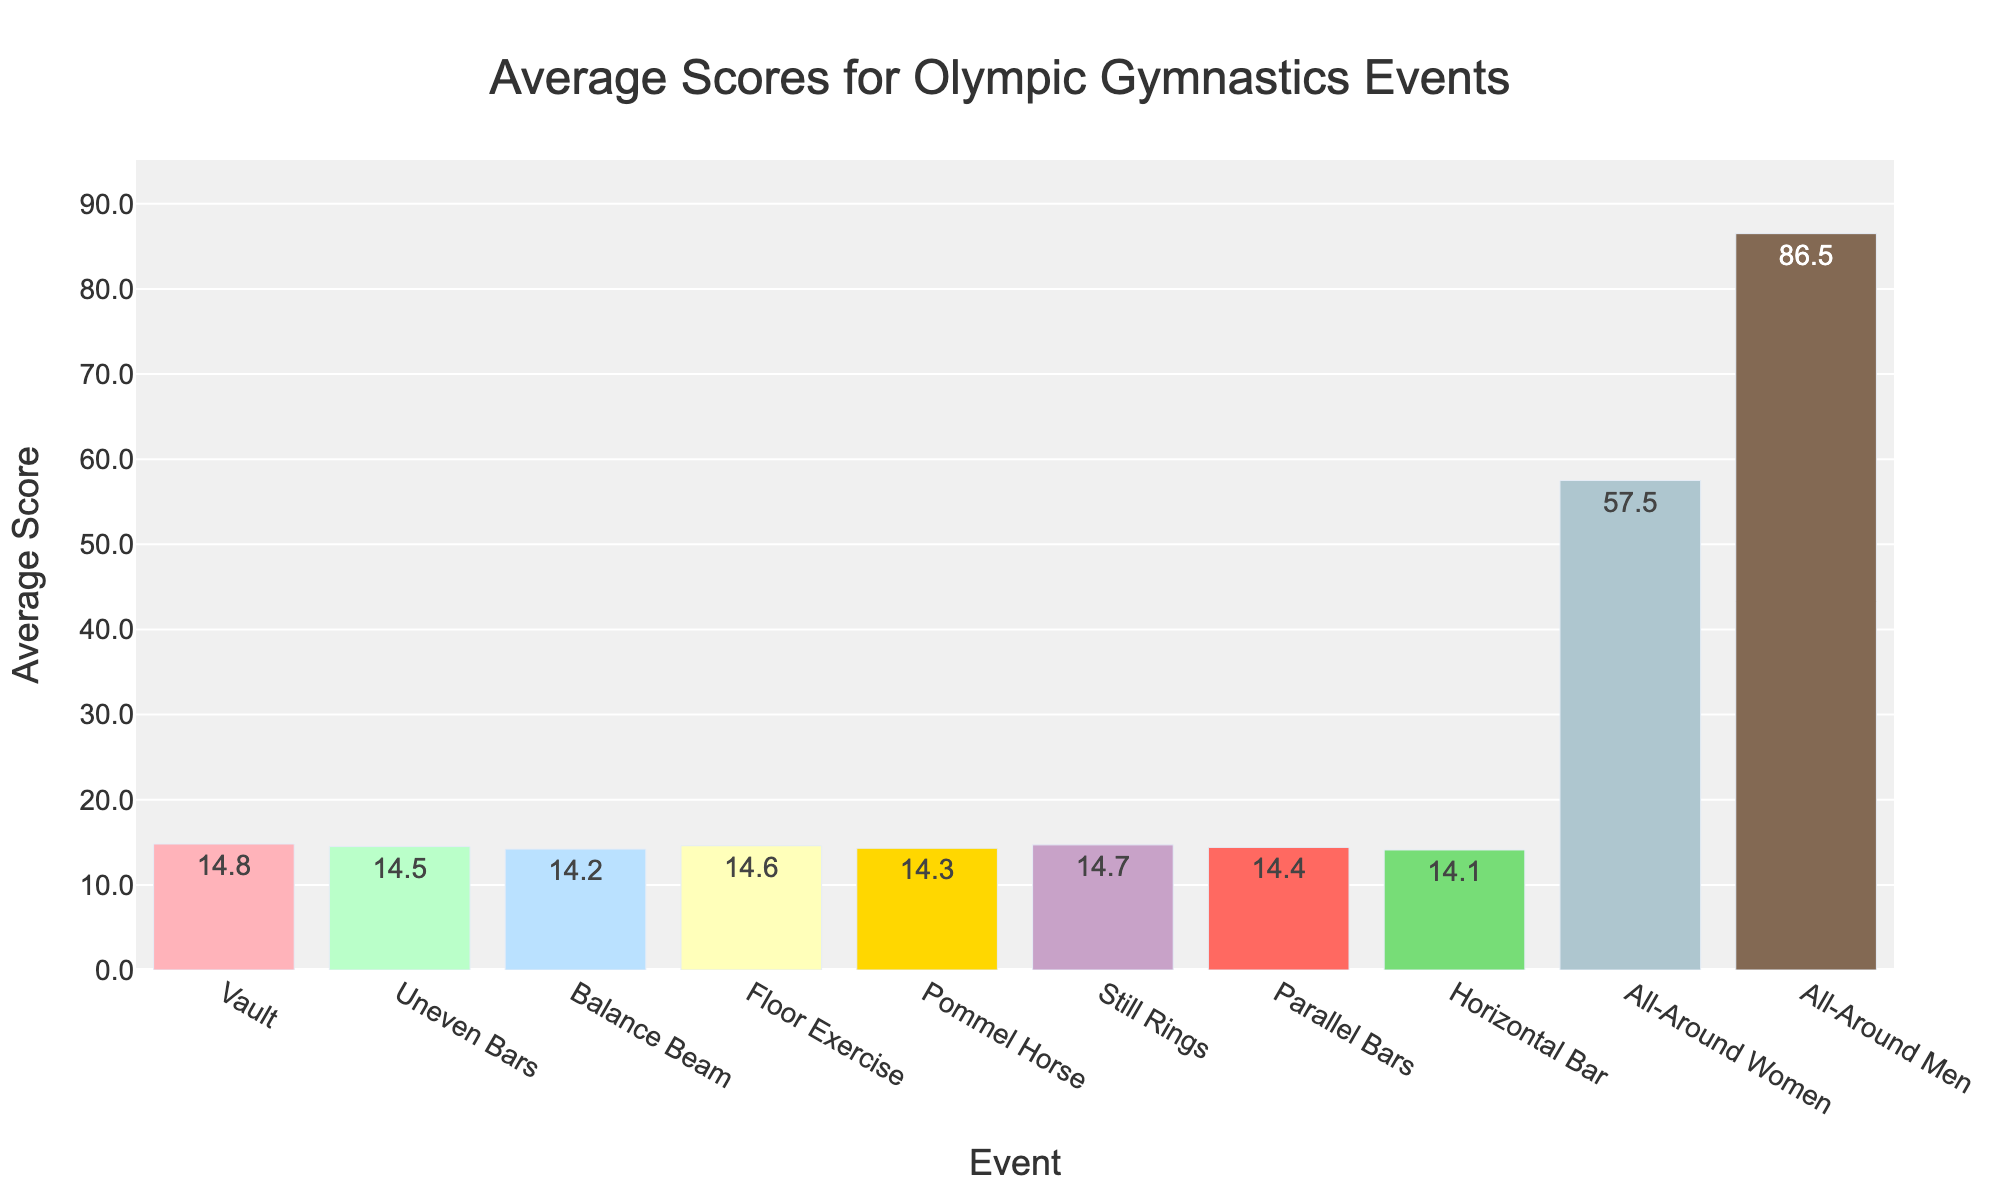What's the event with the highest average score? The highest average score can be identified by finding the tallest bar in the chart, which represents the event. The 'All-Around Men' event has the highest bar with an average score of 86.5.
Answer: All-Around Men Which event has the lowest average score? The event with the lowest average score can be determined by finding the shortest bar in the chart. The 'Horizontal Bar' event has the lowest bar with an average score of 14.1.
Answer: Horizontal Bar What is the difference in average scores between the 'Vault' and 'Balance Beam'? The average score for Vault is 14.8 and for Balance Beam is 14.2. The difference is calculated as 14.8 - 14.2 = 0.6.
Answer: 0.6 Are the average scores for the 'Still Rings' and 'Vault' greater than 14.5? By observing the heights of the bars for 'Still Rings' (14.7) and 'Vault' (14.8), both scores are indeed higher than 14.5.
Answer: Yes What is the combined average score for 'Pommel Horse' and 'Parallel Bars'? The average score for Pommel Horse is 14.3 and for Parallel Bars is 14.4. Summing these values, 14.3 + 14.4 = 28.7.
Answer: 28.7 How much higher is the average score for 'All-Around Women' compared to 'Balance Beam'? The average score for All-Around Women is 57.5, and for Balance Beam, it is 14.2. The difference is 57.5 - 14.2 = 43.3.
Answer: 43.3 Is the average score for 'Floor Exercise' closer to that of 'Uneven Bars' or 'Still Rings'? The average score for Floor Exercise (14.6) is compared to Uneven Bars (14.5) and Still Rings (14.7). The difference to Uneven Bars is 0.1 and to Still Rings is 0.1 as well, making it equidistant.
Answer: Equidistant What is the average of the scores of all the individual apparatus events (excluding All-Around scores)? Summing up the scores: 14.8 (Vault) + 14.5 (Uneven Bars) + 14.2 (Balance Beam) + 14.6 (Floor Exercise) + 14.3 (Pommel Horse) + 14.7 (Still Rings) + 14.4 (Parallel Bars) + 14.1 (Horizontal Bar) = 115.6. Dividing by 8 events, 115.6 / 8 = 14.45.
Answer: 14.45 What is the color of the bar representing the 'Balance Beam' average score? Observing the chart, the bar representing the 'Balance Beam' average score is colored in light blue/sky blue.
Answer: Light Blue/Sky Blue Which event has a slightly lower average score, 'Pommel Horse' or 'Parallel Bars'? By examining the heights of the bars, 'Pommel Horse' has an average score of 14.3 while 'Parallel Bars' has 14.4, making 'Pommel Horse' slightly lower.
Answer: Pommel Horse 